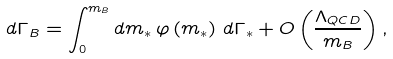<formula> <loc_0><loc_0><loc_500><loc_500>d \Gamma _ { B } = \int _ { 0 } ^ { m _ { B } } d m _ { \ast } \, \varphi \left ( m _ { \ast } \right ) \, d \Gamma _ { \ast } + O \left ( \frac { \Lambda _ { Q C D } } { m _ { B } } \right ) ,</formula> 